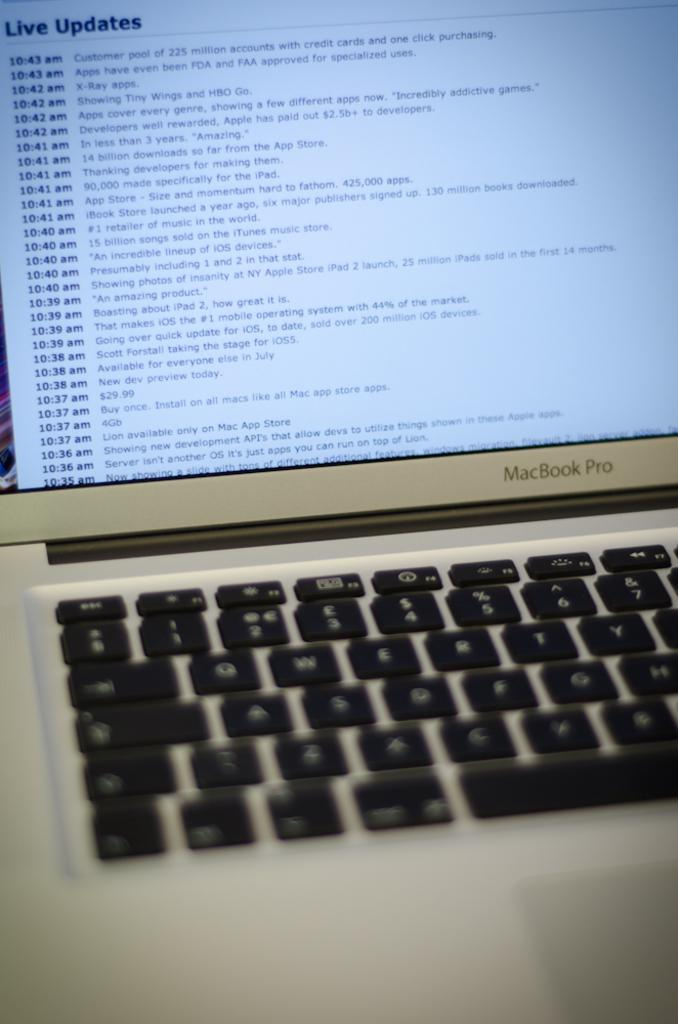<image>
Provide a brief description of the given image. a macbook pro laptop open to a tap of live updates from 10:35 to 10:43 AM 